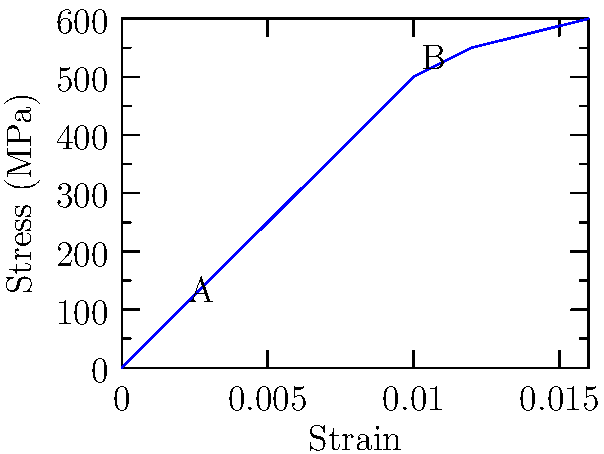The stress-strain curve for a novel alloy developed by a pioneering female materials engineer is shown above. If the material is loaded to point B and then unloaded, what is the permanent strain? Assume linear elastic behavior up to point A. To solve this problem, we need to follow these steps:

1) Identify the yield point (A) and the maximum stress point (B).
   Point A: (0.002, 100 MPa)
   Point B: (0.01, 500 MPa)

2) Calculate Young's modulus using the linear portion up to point A:
   $E = \frac{\text{Stress}}{\text{Strain}} = \frac{100 \text{ MPa}}{0.002} = 50,000 \text{ MPa}$

3) When unloaded from point B, the material will follow a line parallel to the initial elastic portion, with slope E.

4) The equation of this unloading line:
   $\sigma = E(\epsilon - \epsilon_p)$
   Where $\epsilon_p$ is the permanent strain we're looking for.

5) At point B: 500 = 50,000($0.01 - \epsilon_p$)

6) Solve for $\epsilon_p$:
   $\epsilon_p = 0.01 - \frac{500}{50,000} = 0.01 - 0.01 = 0$

7) The permanent strain is the difference between the strain at B and the elastic recovery:
   Permanent strain = $0.01 - 0 = 0.01$
Answer: 0.01 